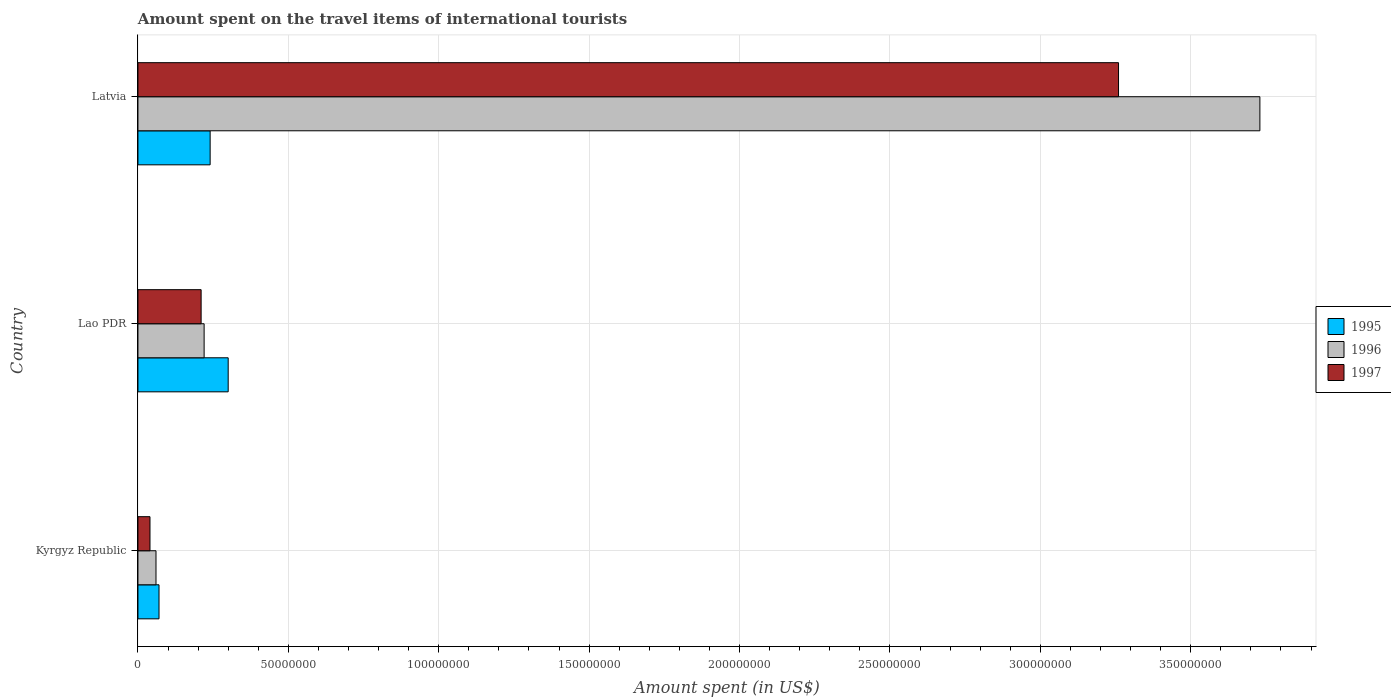How many different coloured bars are there?
Your answer should be compact. 3. What is the label of the 3rd group of bars from the top?
Provide a short and direct response. Kyrgyz Republic. What is the amount spent on the travel items of international tourists in 1997 in Lao PDR?
Provide a succinct answer. 2.10e+07. Across all countries, what is the maximum amount spent on the travel items of international tourists in 1997?
Ensure brevity in your answer.  3.26e+08. Across all countries, what is the minimum amount spent on the travel items of international tourists in 1997?
Keep it short and to the point. 4.00e+06. In which country was the amount spent on the travel items of international tourists in 1997 maximum?
Offer a terse response. Latvia. In which country was the amount spent on the travel items of international tourists in 1997 minimum?
Offer a very short reply. Kyrgyz Republic. What is the total amount spent on the travel items of international tourists in 1997 in the graph?
Make the answer very short. 3.51e+08. What is the difference between the amount spent on the travel items of international tourists in 1997 in Kyrgyz Republic and that in Latvia?
Your response must be concise. -3.22e+08. What is the difference between the amount spent on the travel items of international tourists in 1995 in Lao PDR and the amount spent on the travel items of international tourists in 1997 in Kyrgyz Republic?
Provide a short and direct response. 2.60e+07. What is the average amount spent on the travel items of international tourists in 1996 per country?
Your answer should be compact. 1.34e+08. What is the difference between the amount spent on the travel items of international tourists in 1996 and amount spent on the travel items of international tourists in 1995 in Latvia?
Provide a short and direct response. 3.49e+08. In how many countries, is the amount spent on the travel items of international tourists in 1995 greater than 70000000 US$?
Offer a terse response. 0. Is the amount spent on the travel items of international tourists in 1997 in Lao PDR less than that in Latvia?
Provide a short and direct response. Yes. Is the difference between the amount spent on the travel items of international tourists in 1996 in Kyrgyz Republic and Lao PDR greater than the difference between the amount spent on the travel items of international tourists in 1995 in Kyrgyz Republic and Lao PDR?
Provide a short and direct response. Yes. What is the difference between the highest and the second highest amount spent on the travel items of international tourists in 1995?
Keep it short and to the point. 6.00e+06. What is the difference between the highest and the lowest amount spent on the travel items of international tourists in 1995?
Give a very brief answer. 2.30e+07. In how many countries, is the amount spent on the travel items of international tourists in 1996 greater than the average amount spent on the travel items of international tourists in 1996 taken over all countries?
Your response must be concise. 1. How many bars are there?
Provide a short and direct response. 9. Are all the bars in the graph horizontal?
Your answer should be very brief. Yes. How many countries are there in the graph?
Keep it short and to the point. 3. Are the values on the major ticks of X-axis written in scientific E-notation?
Offer a terse response. No. How many legend labels are there?
Provide a succinct answer. 3. How are the legend labels stacked?
Provide a short and direct response. Vertical. What is the title of the graph?
Provide a succinct answer. Amount spent on the travel items of international tourists. Does "2006" appear as one of the legend labels in the graph?
Your answer should be compact. No. What is the label or title of the X-axis?
Your answer should be very brief. Amount spent (in US$). What is the Amount spent (in US$) in 1996 in Kyrgyz Republic?
Provide a short and direct response. 6.00e+06. What is the Amount spent (in US$) of 1997 in Kyrgyz Republic?
Your answer should be very brief. 4.00e+06. What is the Amount spent (in US$) in 1995 in Lao PDR?
Offer a terse response. 3.00e+07. What is the Amount spent (in US$) in 1996 in Lao PDR?
Offer a very short reply. 2.20e+07. What is the Amount spent (in US$) in 1997 in Lao PDR?
Offer a very short reply. 2.10e+07. What is the Amount spent (in US$) of 1995 in Latvia?
Provide a short and direct response. 2.40e+07. What is the Amount spent (in US$) of 1996 in Latvia?
Your response must be concise. 3.73e+08. What is the Amount spent (in US$) in 1997 in Latvia?
Your answer should be very brief. 3.26e+08. Across all countries, what is the maximum Amount spent (in US$) in 1995?
Offer a terse response. 3.00e+07. Across all countries, what is the maximum Amount spent (in US$) of 1996?
Provide a succinct answer. 3.73e+08. Across all countries, what is the maximum Amount spent (in US$) of 1997?
Your answer should be very brief. 3.26e+08. Across all countries, what is the minimum Amount spent (in US$) in 1995?
Your response must be concise. 7.00e+06. Across all countries, what is the minimum Amount spent (in US$) of 1996?
Offer a very short reply. 6.00e+06. Across all countries, what is the minimum Amount spent (in US$) of 1997?
Give a very brief answer. 4.00e+06. What is the total Amount spent (in US$) in 1995 in the graph?
Offer a terse response. 6.10e+07. What is the total Amount spent (in US$) in 1996 in the graph?
Provide a succinct answer. 4.01e+08. What is the total Amount spent (in US$) of 1997 in the graph?
Your response must be concise. 3.51e+08. What is the difference between the Amount spent (in US$) of 1995 in Kyrgyz Republic and that in Lao PDR?
Your answer should be very brief. -2.30e+07. What is the difference between the Amount spent (in US$) in 1996 in Kyrgyz Republic and that in Lao PDR?
Keep it short and to the point. -1.60e+07. What is the difference between the Amount spent (in US$) in 1997 in Kyrgyz Republic and that in Lao PDR?
Offer a terse response. -1.70e+07. What is the difference between the Amount spent (in US$) of 1995 in Kyrgyz Republic and that in Latvia?
Your answer should be compact. -1.70e+07. What is the difference between the Amount spent (in US$) of 1996 in Kyrgyz Republic and that in Latvia?
Your response must be concise. -3.67e+08. What is the difference between the Amount spent (in US$) in 1997 in Kyrgyz Republic and that in Latvia?
Offer a terse response. -3.22e+08. What is the difference between the Amount spent (in US$) in 1996 in Lao PDR and that in Latvia?
Offer a terse response. -3.51e+08. What is the difference between the Amount spent (in US$) of 1997 in Lao PDR and that in Latvia?
Offer a very short reply. -3.05e+08. What is the difference between the Amount spent (in US$) of 1995 in Kyrgyz Republic and the Amount spent (in US$) of 1996 in Lao PDR?
Your response must be concise. -1.50e+07. What is the difference between the Amount spent (in US$) in 1995 in Kyrgyz Republic and the Amount spent (in US$) in 1997 in Lao PDR?
Your response must be concise. -1.40e+07. What is the difference between the Amount spent (in US$) in 1996 in Kyrgyz Republic and the Amount spent (in US$) in 1997 in Lao PDR?
Offer a terse response. -1.50e+07. What is the difference between the Amount spent (in US$) of 1995 in Kyrgyz Republic and the Amount spent (in US$) of 1996 in Latvia?
Offer a terse response. -3.66e+08. What is the difference between the Amount spent (in US$) in 1995 in Kyrgyz Republic and the Amount spent (in US$) in 1997 in Latvia?
Your response must be concise. -3.19e+08. What is the difference between the Amount spent (in US$) in 1996 in Kyrgyz Republic and the Amount spent (in US$) in 1997 in Latvia?
Keep it short and to the point. -3.20e+08. What is the difference between the Amount spent (in US$) of 1995 in Lao PDR and the Amount spent (in US$) of 1996 in Latvia?
Your answer should be compact. -3.43e+08. What is the difference between the Amount spent (in US$) in 1995 in Lao PDR and the Amount spent (in US$) in 1997 in Latvia?
Ensure brevity in your answer.  -2.96e+08. What is the difference between the Amount spent (in US$) of 1996 in Lao PDR and the Amount spent (in US$) of 1997 in Latvia?
Your answer should be compact. -3.04e+08. What is the average Amount spent (in US$) in 1995 per country?
Give a very brief answer. 2.03e+07. What is the average Amount spent (in US$) of 1996 per country?
Your answer should be very brief. 1.34e+08. What is the average Amount spent (in US$) in 1997 per country?
Offer a very short reply. 1.17e+08. What is the difference between the Amount spent (in US$) of 1995 and Amount spent (in US$) of 1997 in Kyrgyz Republic?
Provide a succinct answer. 3.00e+06. What is the difference between the Amount spent (in US$) in 1996 and Amount spent (in US$) in 1997 in Kyrgyz Republic?
Provide a succinct answer. 2.00e+06. What is the difference between the Amount spent (in US$) of 1995 and Amount spent (in US$) of 1996 in Lao PDR?
Provide a short and direct response. 8.00e+06. What is the difference between the Amount spent (in US$) in 1995 and Amount spent (in US$) in 1997 in Lao PDR?
Provide a succinct answer. 9.00e+06. What is the difference between the Amount spent (in US$) of 1995 and Amount spent (in US$) of 1996 in Latvia?
Provide a short and direct response. -3.49e+08. What is the difference between the Amount spent (in US$) in 1995 and Amount spent (in US$) in 1997 in Latvia?
Make the answer very short. -3.02e+08. What is the difference between the Amount spent (in US$) in 1996 and Amount spent (in US$) in 1997 in Latvia?
Your answer should be compact. 4.70e+07. What is the ratio of the Amount spent (in US$) in 1995 in Kyrgyz Republic to that in Lao PDR?
Offer a very short reply. 0.23. What is the ratio of the Amount spent (in US$) of 1996 in Kyrgyz Republic to that in Lao PDR?
Keep it short and to the point. 0.27. What is the ratio of the Amount spent (in US$) of 1997 in Kyrgyz Republic to that in Lao PDR?
Offer a very short reply. 0.19. What is the ratio of the Amount spent (in US$) of 1995 in Kyrgyz Republic to that in Latvia?
Provide a short and direct response. 0.29. What is the ratio of the Amount spent (in US$) of 1996 in Kyrgyz Republic to that in Latvia?
Keep it short and to the point. 0.02. What is the ratio of the Amount spent (in US$) of 1997 in Kyrgyz Republic to that in Latvia?
Offer a very short reply. 0.01. What is the ratio of the Amount spent (in US$) in 1996 in Lao PDR to that in Latvia?
Ensure brevity in your answer.  0.06. What is the ratio of the Amount spent (in US$) of 1997 in Lao PDR to that in Latvia?
Ensure brevity in your answer.  0.06. What is the difference between the highest and the second highest Amount spent (in US$) in 1995?
Your answer should be very brief. 6.00e+06. What is the difference between the highest and the second highest Amount spent (in US$) in 1996?
Provide a succinct answer. 3.51e+08. What is the difference between the highest and the second highest Amount spent (in US$) of 1997?
Ensure brevity in your answer.  3.05e+08. What is the difference between the highest and the lowest Amount spent (in US$) of 1995?
Provide a succinct answer. 2.30e+07. What is the difference between the highest and the lowest Amount spent (in US$) of 1996?
Ensure brevity in your answer.  3.67e+08. What is the difference between the highest and the lowest Amount spent (in US$) of 1997?
Give a very brief answer. 3.22e+08. 